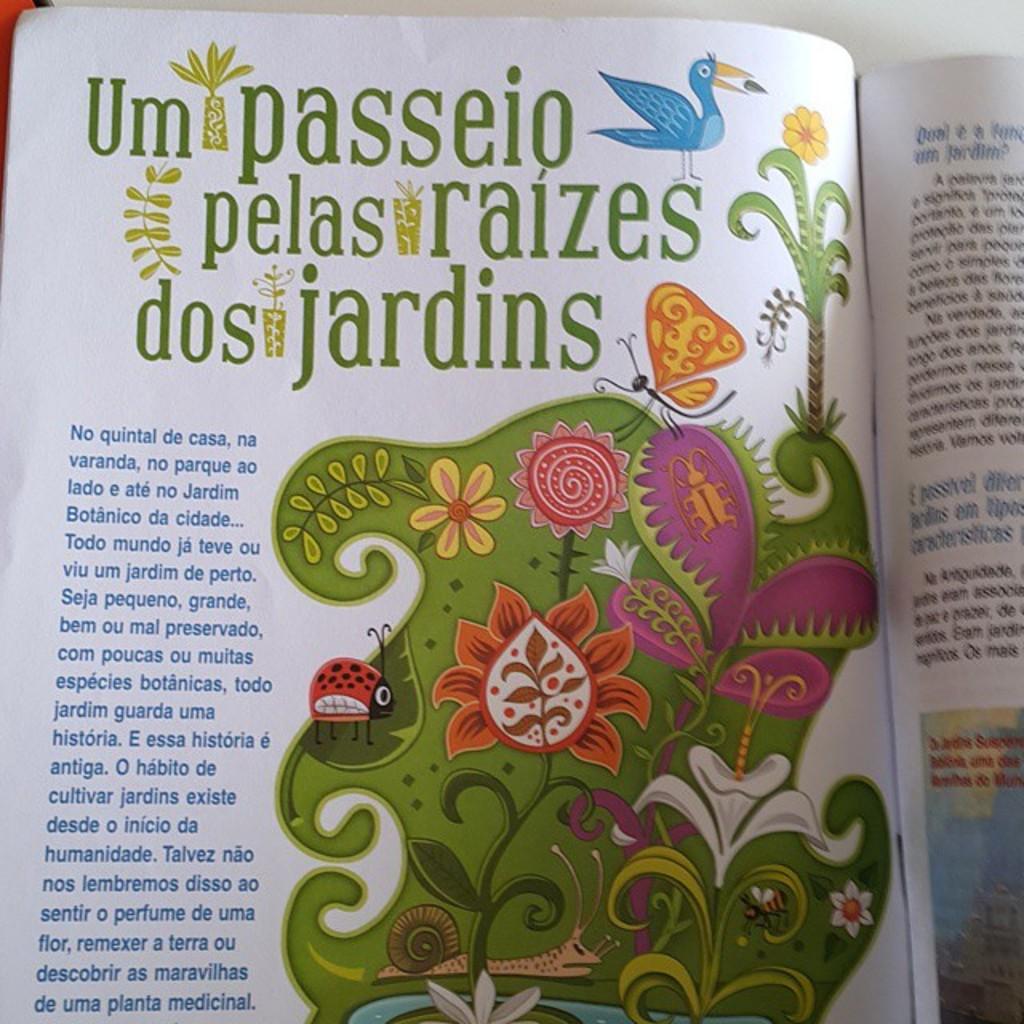What is the title of the article?
Ensure brevity in your answer.  Um passeio pelas raizes dos jardins. 